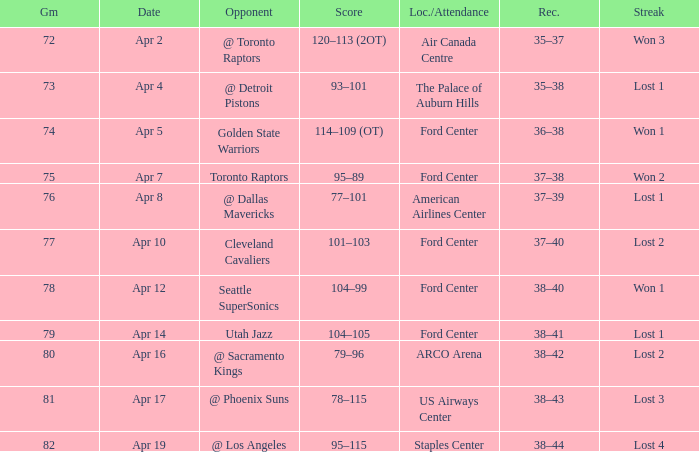What was the record for less than 78 games and a score of 114–109 (ot)? 36–38. 